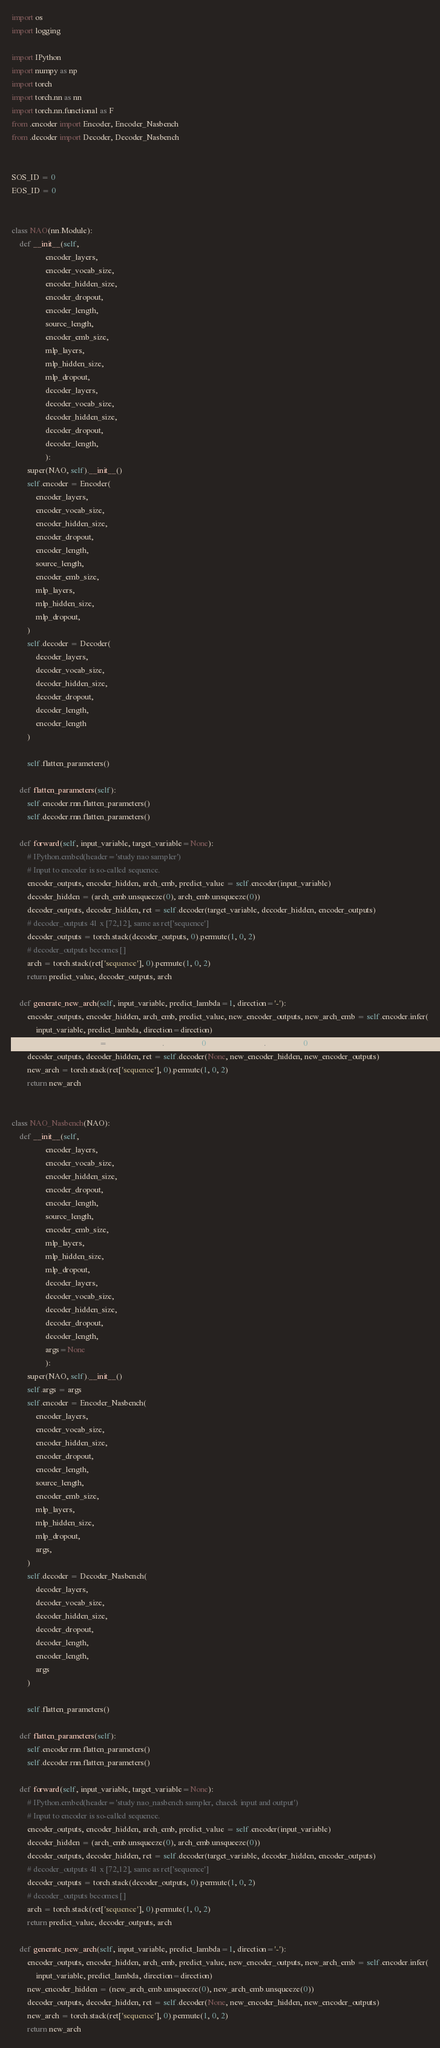Convert code to text. <code><loc_0><loc_0><loc_500><loc_500><_Python_>import os
import logging

import IPython
import numpy as np
import torch
import torch.nn as nn
import torch.nn.functional as F
from .encoder import Encoder, Encoder_Nasbench
from .decoder import Decoder, Decoder_Nasbench


SOS_ID = 0
EOS_ID = 0


class NAO(nn.Module):
    def __init__(self,
                 encoder_layers,
                 encoder_vocab_size,
                 encoder_hidden_size,
                 encoder_dropout,
                 encoder_length,
                 source_length,
                 encoder_emb_size,
                 mlp_layers,
                 mlp_hidden_size,
                 mlp_dropout,
                 decoder_layers,
                 decoder_vocab_size,
                 decoder_hidden_size,
                 decoder_dropout,
                 decoder_length,
                 ):
        super(NAO, self).__init__()
        self.encoder = Encoder(
            encoder_layers,
            encoder_vocab_size,
            encoder_hidden_size,
            encoder_dropout,
            encoder_length,
            source_length,
            encoder_emb_size,
            mlp_layers,
            mlp_hidden_size,
            mlp_dropout,
        )
        self.decoder = Decoder(
            decoder_layers,
            decoder_vocab_size,
            decoder_hidden_size,
            decoder_dropout,
            decoder_length,
            encoder_length
        )

        self.flatten_parameters()
    
    def flatten_parameters(self):
        self.encoder.rnn.flatten_parameters()
        self.decoder.rnn.flatten_parameters()
    
    def forward(self, input_variable, target_variable=None):
        # IPython.embed(header='study nao sampler')
        # Input to encoder is so-called sequence.
        encoder_outputs, encoder_hidden, arch_emb, predict_value = self.encoder(input_variable)
        decoder_hidden = (arch_emb.unsqueeze(0), arch_emb.unsqueeze(0))
        decoder_outputs, decoder_hidden, ret = self.decoder(target_variable, decoder_hidden, encoder_outputs)
        # decoder_outputs 41 x [72,12], same as ret['sequence']
        decoder_outputs = torch.stack(decoder_outputs, 0).permute(1, 0, 2)
        # decoder_outputs becomes []
        arch = torch.stack(ret['sequence'], 0).permute(1, 0, 2)
        return predict_value, decoder_outputs, arch
    
    def generate_new_arch(self, input_variable, predict_lambda=1, direction='-'):
        encoder_outputs, encoder_hidden, arch_emb, predict_value, new_encoder_outputs, new_arch_emb = self.encoder.infer(
            input_variable, predict_lambda, direction=direction)
        new_encoder_hidden = (new_arch_emb.unsqueeze(0), new_arch_emb.unsqueeze(0))
        decoder_outputs, decoder_hidden, ret = self.decoder(None, new_encoder_hidden, new_encoder_outputs)
        new_arch = torch.stack(ret['sequence'], 0).permute(1, 0, 2)
        return new_arch


class NAO_Nasbench(NAO):
    def __init__(self,
                 encoder_layers,
                 encoder_vocab_size,
                 encoder_hidden_size,
                 encoder_dropout,
                 encoder_length,
                 source_length,
                 encoder_emb_size,
                 mlp_layers,
                 mlp_hidden_size,
                 mlp_dropout,
                 decoder_layers,
                 decoder_vocab_size,
                 decoder_hidden_size,
                 decoder_dropout,
                 decoder_length,
                 args=None
                 ):
        super(NAO, self).__init__()
        self.args = args
        self.encoder = Encoder_Nasbench(
            encoder_layers,
            encoder_vocab_size,
            encoder_hidden_size,
            encoder_dropout,
            encoder_length,
            source_length,
            encoder_emb_size,
            mlp_layers,
            mlp_hidden_size,
            mlp_dropout,
            args,
        )
        self.decoder = Decoder_Nasbench(
            decoder_layers,
            decoder_vocab_size,
            decoder_hidden_size,
            decoder_dropout,
            decoder_length,
            encoder_length,
            args
        )

        self.flatten_parameters()

    def flatten_parameters(self):
        self.encoder.rnn.flatten_parameters()
        self.decoder.rnn.flatten_parameters()

    def forward(self, input_variable, target_variable=None):
        # IPython.embed(header='study nao_nasbench sampler, chaeck input and output')
        # Input to encoder is so-called sequence.
        encoder_outputs, encoder_hidden, arch_emb, predict_value = self.encoder(input_variable)
        decoder_hidden = (arch_emb.unsqueeze(0), arch_emb.unsqueeze(0))
        decoder_outputs, decoder_hidden, ret = self.decoder(target_variable, decoder_hidden, encoder_outputs)
        # decoder_outputs 41 x [72,12], same as ret['sequence']
        decoder_outputs = torch.stack(decoder_outputs, 0).permute(1, 0, 2)
        # decoder_outputs becomes []
        arch = torch.stack(ret['sequence'], 0).permute(1, 0, 2)
        return predict_value, decoder_outputs, arch

    def generate_new_arch(self, input_variable, predict_lambda=1, direction='-'):
        encoder_outputs, encoder_hidden, arch_emb, predict_value, new_encoder_outputs, new_arch_emb = self.encoder.infer(
            input_variable, predict_lambda, direction=direction)
        new_encoder_hidden = (new_arch_emb.unsqueeze(0), new_arch_emb.unsqueeze(0))
        decoder_outputs, decoder_hidden, ret = self.decoder(None, new_encoder_hidden, new_encoder_outputs)
        new_arch = torch.stack(ret['sequence'], 0).permute(1, 0, 2)
        return new_arch</code> 